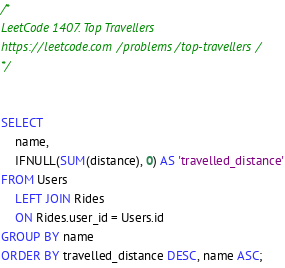<code> <loc_0><loc_0><loc_500><loc_500><_SQL_>/*
LeetCode 1407. Top Travellers
https://leetcode.com/problems/top-travellers/
*/


SELECT
    name,
    IFNULL(SUM(distance), 0) AS 'travelled_distance'
FROM Users
    LEFT JOIN Rides
    ON Rides.user_id = Users.id
GROUP BY name
ORDER BY travelled_distance DESC, name ASC;</code> 